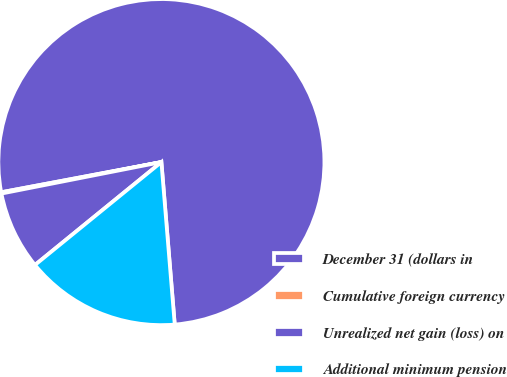<chart> <loc_0><loc_0><loc_500><loc_500><pie_chart><fcel>December 31 (dollars in<fcel>Cumulative foreign currency<fcel>Unrealized net gain (loss) on<fcel>Additional minimum pension<nl><fcel>76.65%<fcel>0.13%<fcel>7.78%<fcel>15.43%<nl></chart> 